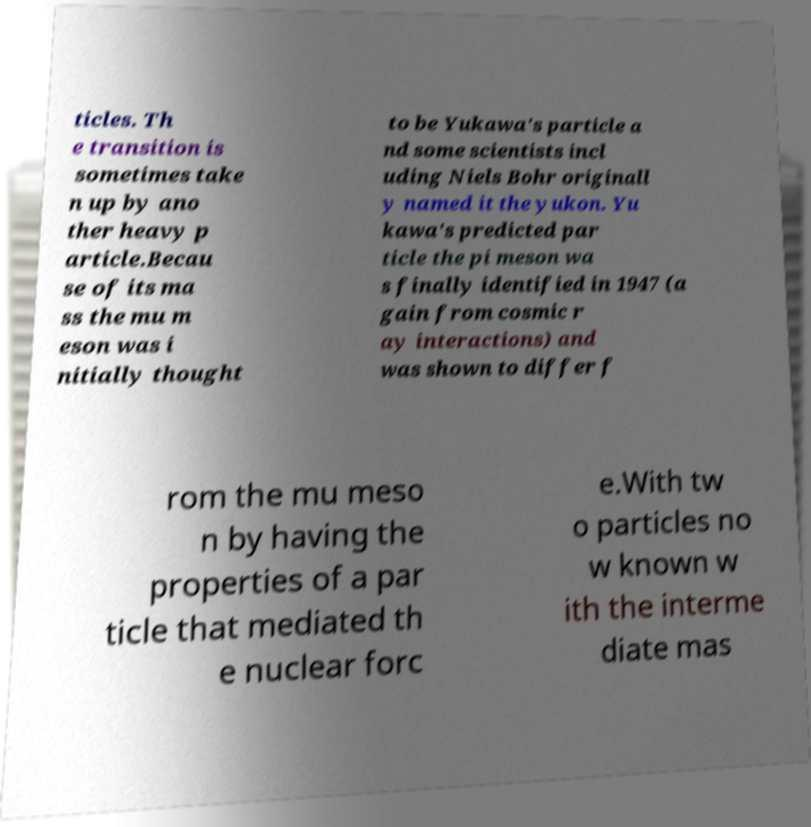Could you extract and type out the text from this image? ticles. Th e transition is sometimes take n up by ano ther heavy p article.Becau se of its ma ss the mu m eson was i nitially thought to be Yukawa's particle a nd some scientists incl uding Niels Bohr originall y named it the yukon. Yu kawa's predicted par ticle the pi meson wa s finally identified in 1947 (a gain from cosmic r ay interactions) and was shown to differ f rom the mu meso n by having the properties of a par ticle that mediated th e nuclear forc e.With tw o particles no w known w ith the interme diate mas 